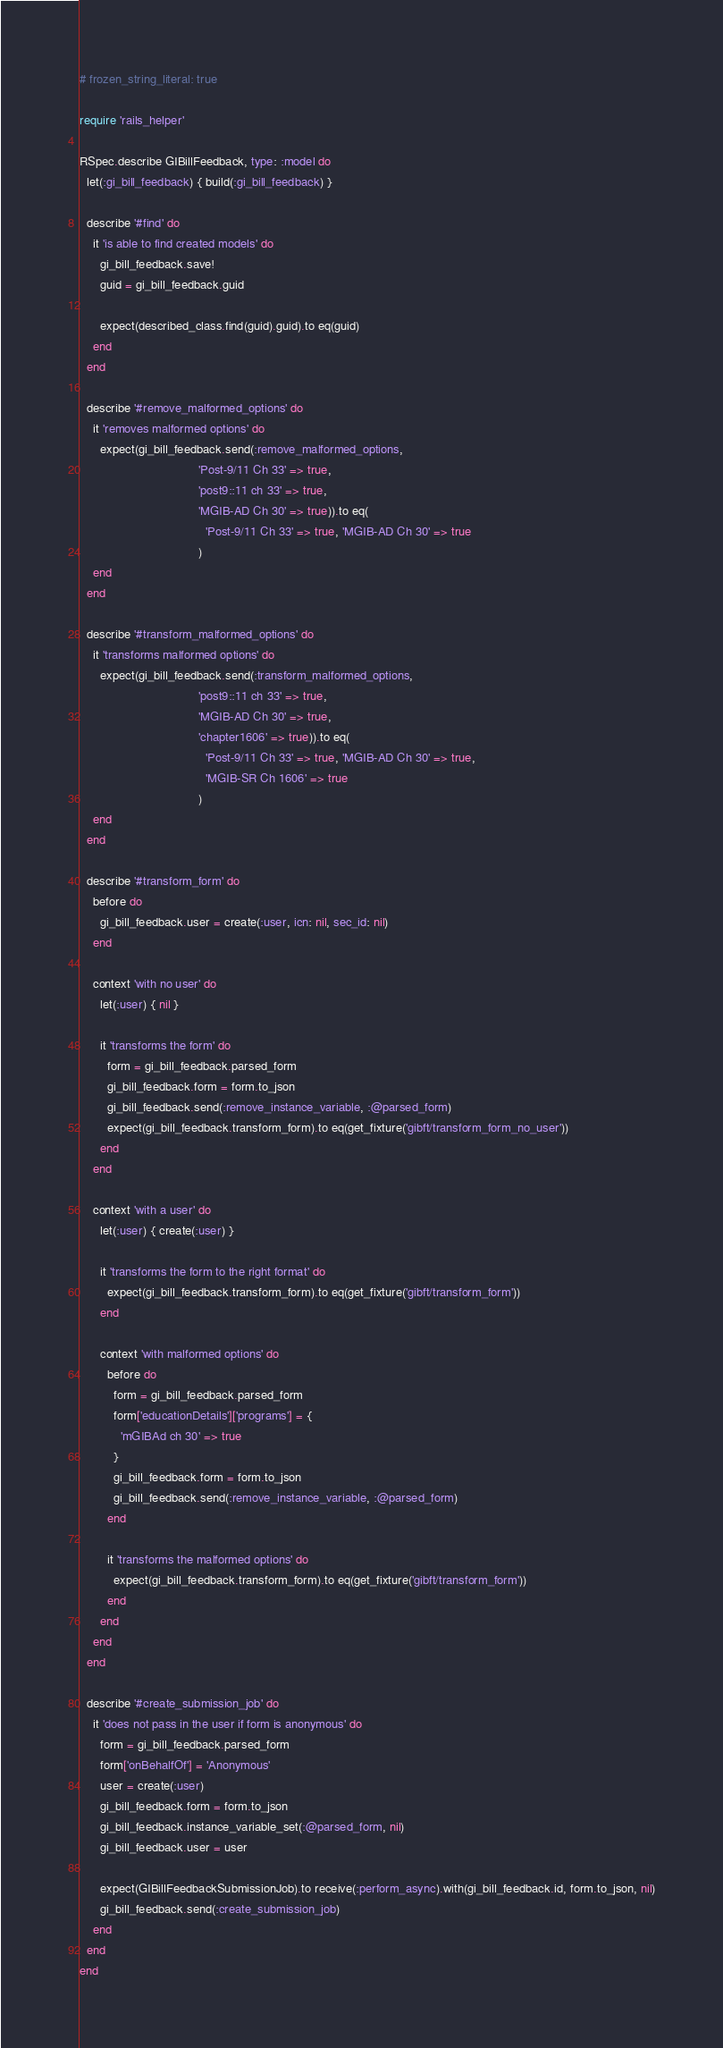Convert code to text. <code><loc_0><loc_0><loc_500><loc_500><_Ruby_># frozen_string_literal: true

require 'rails_helper'

RSpec.describe GIBillFeedback, type: :model do
  let(:gi_bill_feedback) { build(:gi_bill_feedback) }

  describe '#find' do
    it 'is able to find created models' do
      gi_bill_feedback.save!
      guid = gi_bill_feedback.guid

      expect(described_class.find(guid).guid).to eq(guid)
    end
  end

  describe '#remove_malformed_options' do
    it 'removes malformed options' do
      expect(gi_bill_feedback.send(:remove_malformed_options,
                                   'Post-9/11 Ch 33' => true,
                                   'post9::11 ch 33' => true,
                                   'MGIB-AD Ch 30' => true)).to eq(
                                     'Post-9/11 Ch 33' => true, 'MGIB-AD Ch 30' => true
                                   )
    end
  end

  describe '#transform_malformed_options' do
    it 'transforms malformed options' do
      expect(gi_bill_feedback.send(:transform_malformed_options,
                                   'post9::11 ch 33' => true,
                                   'MGIB-AD Ch 30' => true,
                                   'chapter1606' => true)).to eq(
                                     'Post-9/11 Ch 33' => true, 'MGIB-AD Ch 30' => true,
                                     'MGIB-SR Ch 1606' => true
                                   )
    end
  end

  describe '#transform_form' do
    before do
      gi_bill_feedback.user = create(:user, icn: nil, sec_id: nil)
    end

    context 'with no user' do
      let(:user) { nil }

      it 'transforms the form' do
        form = gi_bill_feedback.parsed_form
        gi_bill_feedback.form = form.to_json
        gi_bill_feedback.send(:remove_instance_variable, :@parsed_form)
        expect(gi_bill_feedback.transform_form).to eq(get_fixture('gibft/transform_form_no_user'))
      end
    end

    context 'with a user' do
      let(:user) { create(:user) }

      it 'transforms the form to the right format' do
        expect(gi_bill_feedback.transform_form).to eq(get_fixture('gibft/transform_form'))
      end

      context 'with malformed options' do
        before do
          form = gi_bill_feedback.parsed_form
          form['educationDetails']['programs'] = {
            'mGIBAd ch 30' => true
          }
          gi_bill_feedback.form = form.to_json
          gi_bill_feedback.send(:remove_instance_variable, :@parsed_form)
        end

        it 'transforms the malformed options' do
          expect(gi_bill_feedback.transform_form).to eq(get_fixture('gibft/transform_form'))
        end
      end
    end
  end

  describe '#create_submission_job' do
    it 'does not pass in the user if form is anonymous' do
      form = gi_bill_feedback.parsed_form
      form['onBehalfOf'] = 'Anonymous'
      user = create(:user)
      gi_bill_feedback.form = form.to_json
      gi_bill_feedback.instance_variable_set(:@parsed_form, nil)
      gi_bill_feedback.user = user

      expect(GIBillFeedbackSubmissionJob).to receive(:perform_async).with(gi_bill_feedback.id, form.to_json, nil)
      gi_bill_feedback.send(:create_submission_job)
    end
  end
end
</code> 